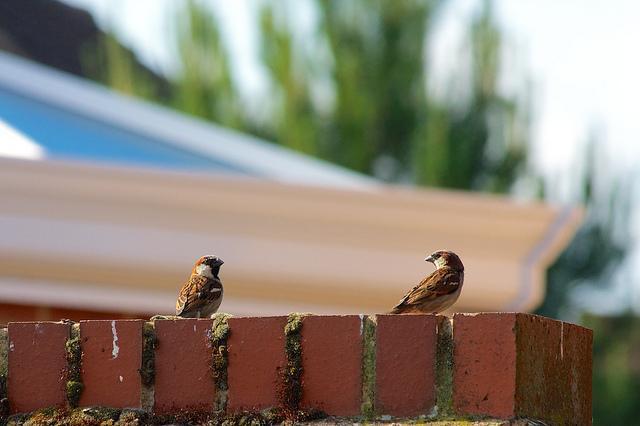How many birds are on the wall?
Give a very brief answer. 2. How many birds are in the photo?
Give a very brief answer. 2. How many birds are there?
Give a very brief answer. 2. 